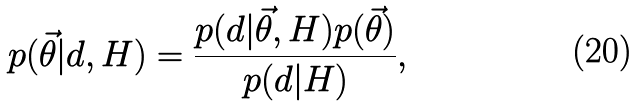Convert formula to latex. <formula><loc_0><loc_0><loc_500><loc_500>p ( \vec { \theta } | d , H ) = \frac { p ( d | \vec { \theta } , H ) p ( \vec { \theta } ) } { p ( d | H ) } ,</formula> 